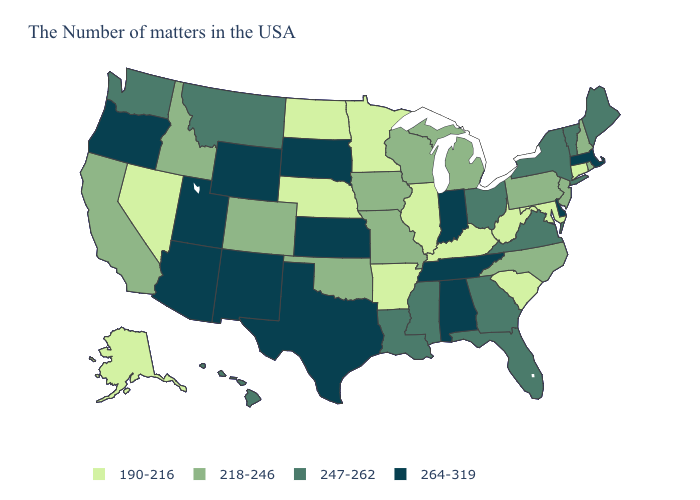Among the states that border Wyoming , does Nebraska have the highest value?
Keep it brief. No. Name the states that have a value in the range 264-319?
Answer briefly. Massachusetts, Delaware, Indiana, Alabama, Tennessee, Kansas, Texas, South Dakota, Wyoming, New Mexico, Utah, Arizona, Oregon. Does the first symbol in the legend represent the smallest category?
Answer briefly. Yes. Which states have the lowest value in the Northeast?
Give a very brief answer. Connecticut. Name the states that have a value in the range 264-319?
Answer briefly. Massachusetts, Delaware, Indiana, Alabama, Tennessee, Kansas, Texas, South Dakota, Wyoming, New Mexico, Utah, Arizona, Oregon. Does the first symbol in the legend represent the smallest category?
Give a very brief answer. Yes. Among the states that border Illinois , does Iowa have the lowest value?
Keep it brief. No. Does the first symbol in the legend represent the smallest category?
Write a very short answer. Yes. Name the states that have a value in the range 247-262?
Keep it brief. Maine, Vermont, New York, Virginia, Ohio, Florida, Georgia, Mississippi, Louisiana, Montana, Washington, Hawaii. Does the first symbol in the legend represent the smallest category?
Short answer required. Yes. Which states hav the highest value in the South?
Concise answer only. Delaware, Alabama, Tennessee, Texas. Does California have the lowest value in the USA?
Be succinct. No. Name the states that have a value in the range 264-319?
Quick response, please. Massachusetts, Delaware, Indiana, Alabama, Tennessee, Kansas, Texas, South Dakota, Wyoming, New Mexico, Utah, Arizona, Oregon. Does Minnesota have the lowest value in the MidWest?
Keep it brief. Yes. 